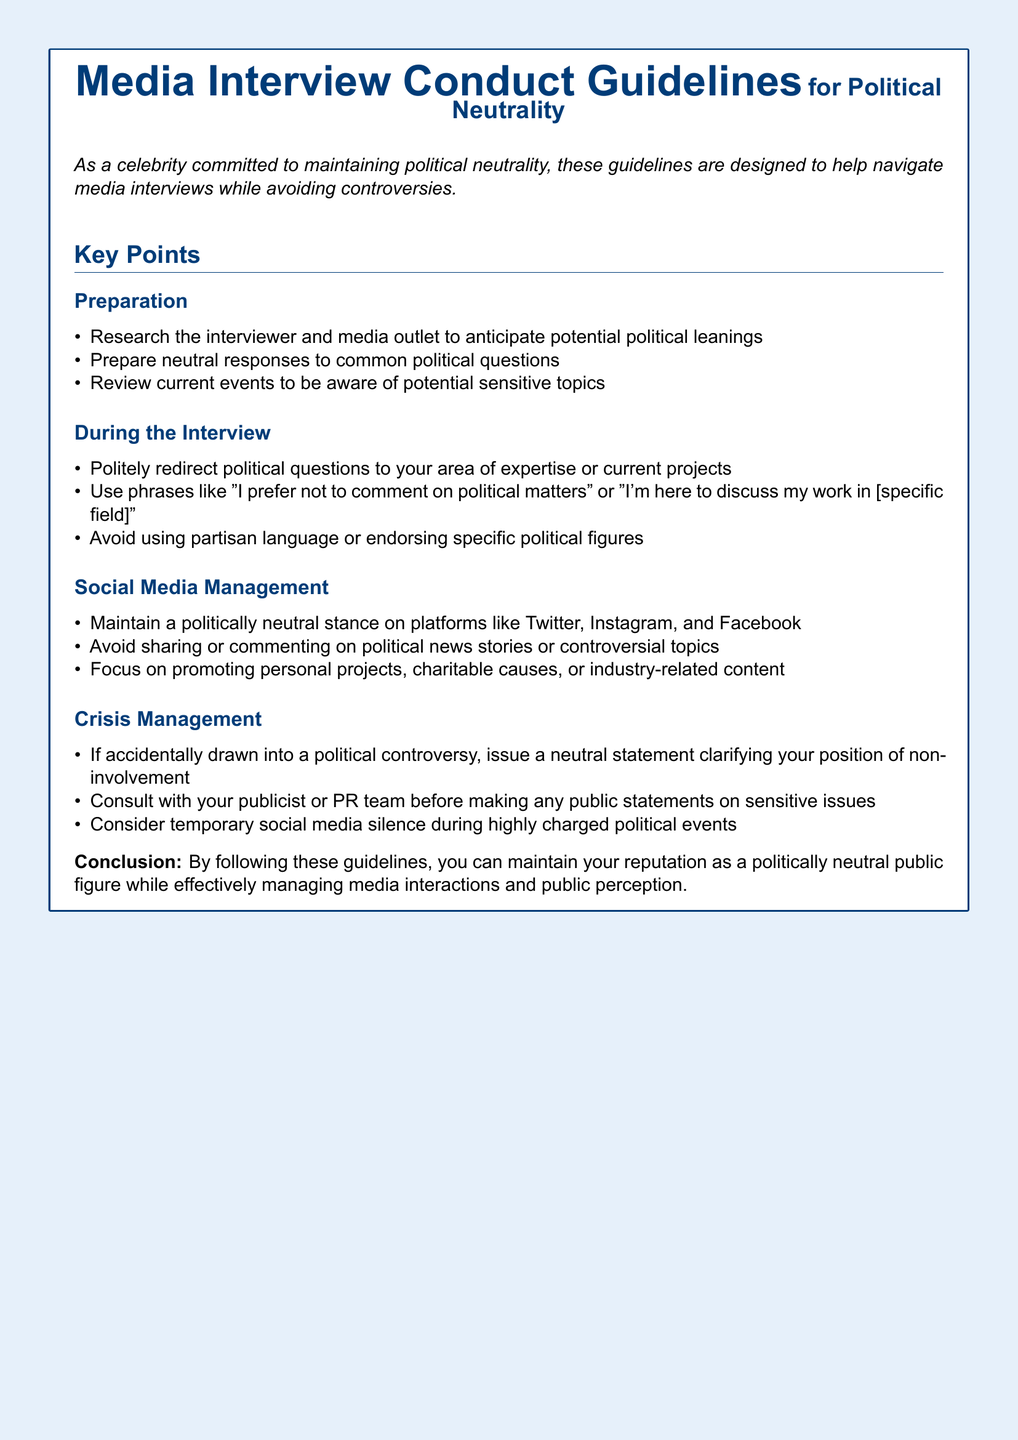What is the title of the document? The title is presented prominently at the top of the document.
Answer: Media Interview Conduct Guidelines for Political Neutrality What is the purpose of the guidelines? The document states the purpose in the introduction section.
Answer: To help navigate media interviews while avoiding controversies How many sections are in the key points? The details of the key points are listed along with their subsections.
Answer: Four What phrase should be used to redirect political questions? The guidelines suggest specific phrases to handle sensitive questions.
Answer: I prefer not to comment on political matters What should you do if drawn into a political controversy? The crisis management section advises on the appropriate response.
Answer: Issue a neutral statement clarifying your position of non-involvement What social media stance is recommended? The document outlines the approach to managing social media content.
Answer: Politically neutral What should you focus on promoting on social media? The guidelines recommend specific types of content to share.
Answer: Personal projects, charitable causes, or industry-related content How should you prepare for potential sensitive topics? The guidelines suggest a specific course of action in the preparation section.
Answer: Review current events What is advised before making public statements on sensitive issues? The crisis management section emphasizes the need for coordination.
Answer: Consult with your publicist or PR team 